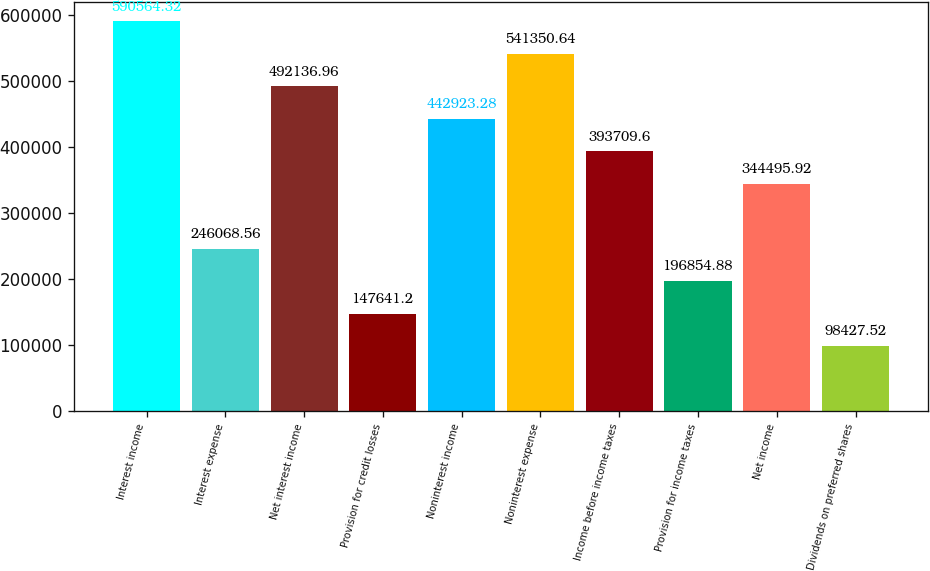Convert chart. <chart><loc_0><loc_0><loc_500><loc_500><bar_chart><fcel>Interest income<fcel>Interest expense<fcel>Net interest income<fcel>Provision for credit losses<fcel>Noninterest income<fcel>Noninterest expense<fcel>Income before income taxes<fcel>Provision for income taxes<fcel>Net income<fcel>Dividends on preferred shares<nl><fcel>590564<fcel>246069<fcel>492137<fcel>147641<fcel>442923<fcel>541351<fcel>393710<fcel>196855<fcel>344496<fcel>98427.5<nl></chart> 